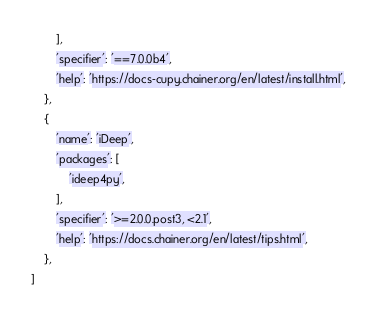Convert code to text. <code><loc_0><loc_0><loc_500><loc_500><_Python_>        ],
        'specifier': '==7.0.0b4',
        'help': 'https://docs-cupy.chainer.org/en/latest/install.html',
    },
    {
        'name': 'iDeep',
        'packages': [
            'ideep4py',
        ],
        'specifier': '>=2.0.0.post3, <2.1',
        'help': 'https://docs.chainer.org/en/latest/tips.html',
    },
]
</code> 